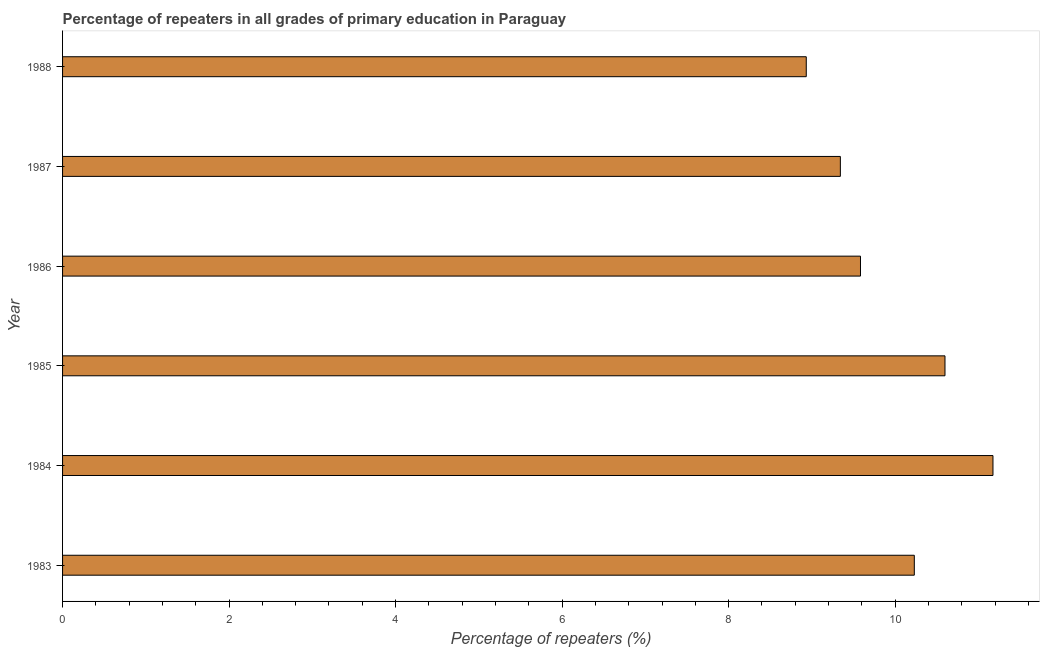Does the graph contain any zero values?
Provide a succinct answer. No. What is the title of the graph?
Keep it short and to the point. Percentage of repeaters in all grades of primary education in Paraguay. What is the label or title of the X-axis?
Ensure brevity in your answer.  Percentage of repeaters (%). What is the label or title of the Y-axis?
Your answer should be very brief. Year. What is the percentage of repeaters in primary education in 1988?
Offer a very short reply. 8.93. Across all years, what is the maximum percentage of repeaters in primary education?
Make the answer very short. 11.18. Across all years, what is the minimum percentage of repeaters in primary education?
Your answer should be compact. 8.93. In which year was the percentage of repeaters in primary education maximum?
Give a very brief answer. 1984. In which year was the percentage of repeaters in primary education minimum?
Offer a very short reply. 1988. What is the sum of the percentage of repeaters in primary education?
Keep it short and to the point. 59.86. What is the difference between the percentage of repeaters in primary education in 1985 and 1988?
Your response must be concise. 1.67. What is the average percentage of repeaters in primary education per year?
Provide a short and direct response. 9.98. What is the median percentage of repeaters in primary education?
Ensure brevity in your answer.  9.91. Is the difference between the percentage of repeaters in primary education in 1983 and 1986 greater than the difference between any two years?
Give a very brief answer. No. What is the difference between the highest and the second highest percentage of repeaters in primary education?
Your answer should be very brief. 0.58. Is the sum of the percentage of repeaters in primary education in 1984 and 1985 greater than the maximum percentage of repeaters in primary education across all years?
Provide a short and direct response. Yes. What is the difference between the highest and the lowest percentage of repeaters in primary education?
Ensure brevity in your answer.  2.24. How many years are there in the graph?
Make the answer very short. 6. What is the difference between two consecutive major ticks on the X-axis?
Give a very brief answer. 2. Are the values on the major ticks of X-axis written in scientific E-notation?
Make the answer very short. No. What is the Percentage of repeaters (%) in 1983?
Offer a very short reply. 10.23. What is the Percentage of repeaters (%) of 1984?
Your answer should be compact. 11.18. What is the Percentage of repeaters (%) of 1985?
Ensure brevity in your answer.  10.6. What is the Percentage of repeaters (%) of 1986?
Offer a terse response. 9.58. What is the Percentage of repeaters (%) of 1987?
Offer a very short reply. 9.34. What is the Percentage of repeaters (%) in 1988?
Give a very brief answer. 8.93. What is the difference between the Percentage of repeaters (%) in 1983 and 1984?
Offer a terse response. -0.94. What is the difference between the Percentage of repeaters (%) in 1983 and 1985?
Your response must be concise. -0.37. What is the difference between the Percentage of repeaters (%) in 1983 and 1986?
Keep it short and to the point. 0.65. What is the difference between the Percentage of repeaters (%) in 1983 and 1987?
Offer a terse response. 0.89. What is the difference between the Percentage of repeaters (%) in 1983 and 1988?
Offer a terse response. 1.3. What is the difference between the Percentage of repeaters (%) in 1984 and 1985?
Provide a succinct answer. 0.58. What is the difference between the Percentage of repeaters (%) in 1984 and 1986?
Give a very brief answer. 1.59. What is the difference between the Percentage of repeaters (%) in 1984 and 1987?
Your response must be concise. 1.83. What is the difference between the Percentage of repeaters (%) in 1984 and 1988?
Offer a very short reply. 2.24. What is the difference between the Percentage of repeaters (%) in 1985 and 1986?
Your response must be concise. 1.01. What is the difference between the Percentage of repeaters (%) in 1985 and 1987?
Keep it short and to the point. 1.26. What is the difference between the Percentage of repeaters (%) in 1985 and 1988?
Give a very brief answer. 1.67. What is the difference between the Percentage of repeaters (%) in 1986 and 1987?
Keep it short and to the point. 0.24. What is the difference between the Percentage of repeaters (%) in 1986 and 1988?
Your answer should be compact. 0.65. What is the difference between the Percentage of repeaters (%) in 1987 and 1988?
Provide a short and direct response. 0.41. What is the ratio of the Percentage of repeaters (%) in 1983 to that in 1984?
Your answer should be very brief. 0.92. What is the ratio of the Percentage of repeaters (%) in 1983 to that in 1986?
Make the answer very short. 1.07. What is the ratio of the Percentage of repeaters (%) in 1983 to that in 1987?
Offer a terse response. 1.09. What is the ratio of the Percentage of repeaters (%) in 1983 to that in 1988?
Your answer should be compact. 1.15. What is the ratio of the Percentage of repeaters (%) in 1984 to that in 1985?
Give a very brief answer. 1.05. What is the ratio of the Percentage of repeaters (%) in 1984 to that in 1986?
Ensure brevity in your answer.  1.17. What is the ratio of the Percentage of repeaters (%) in 1984 to that in 1987?
Your response must be concise. 1.2. What is the ratio of the Percentage of repeaters (%) in 1984 to that in 1988?
Offer a terse response. 1.25. What is the ratio of the Percentage of repeaters (%) in 1985 to that in 1986?
Keep it short and to the point. 1.11. What is the ratio of the Percentage of repeaters (%) in 1985 to that in 1987?
Provide a succinct answer. 1.14. What is the ratio of the Percentage of repeaters (%) in 1985 to that in 1988?
Make the answer very short. 1.19. What is the ratio of the Percentage of repeaters (%) in 1986 to that in 1988?
Ensure brevity in your answer.  1.07. What is the ratio of the Percentage of repeaters (%) in 1987 to that in 1988?
Your response must be concise. 1.05. 